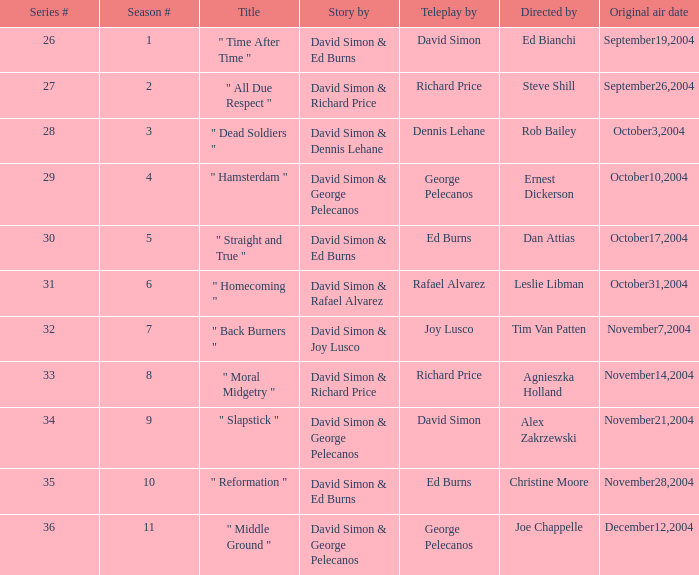What is the total number of values for "Teleplay by" category for series # 35? 1.0. 